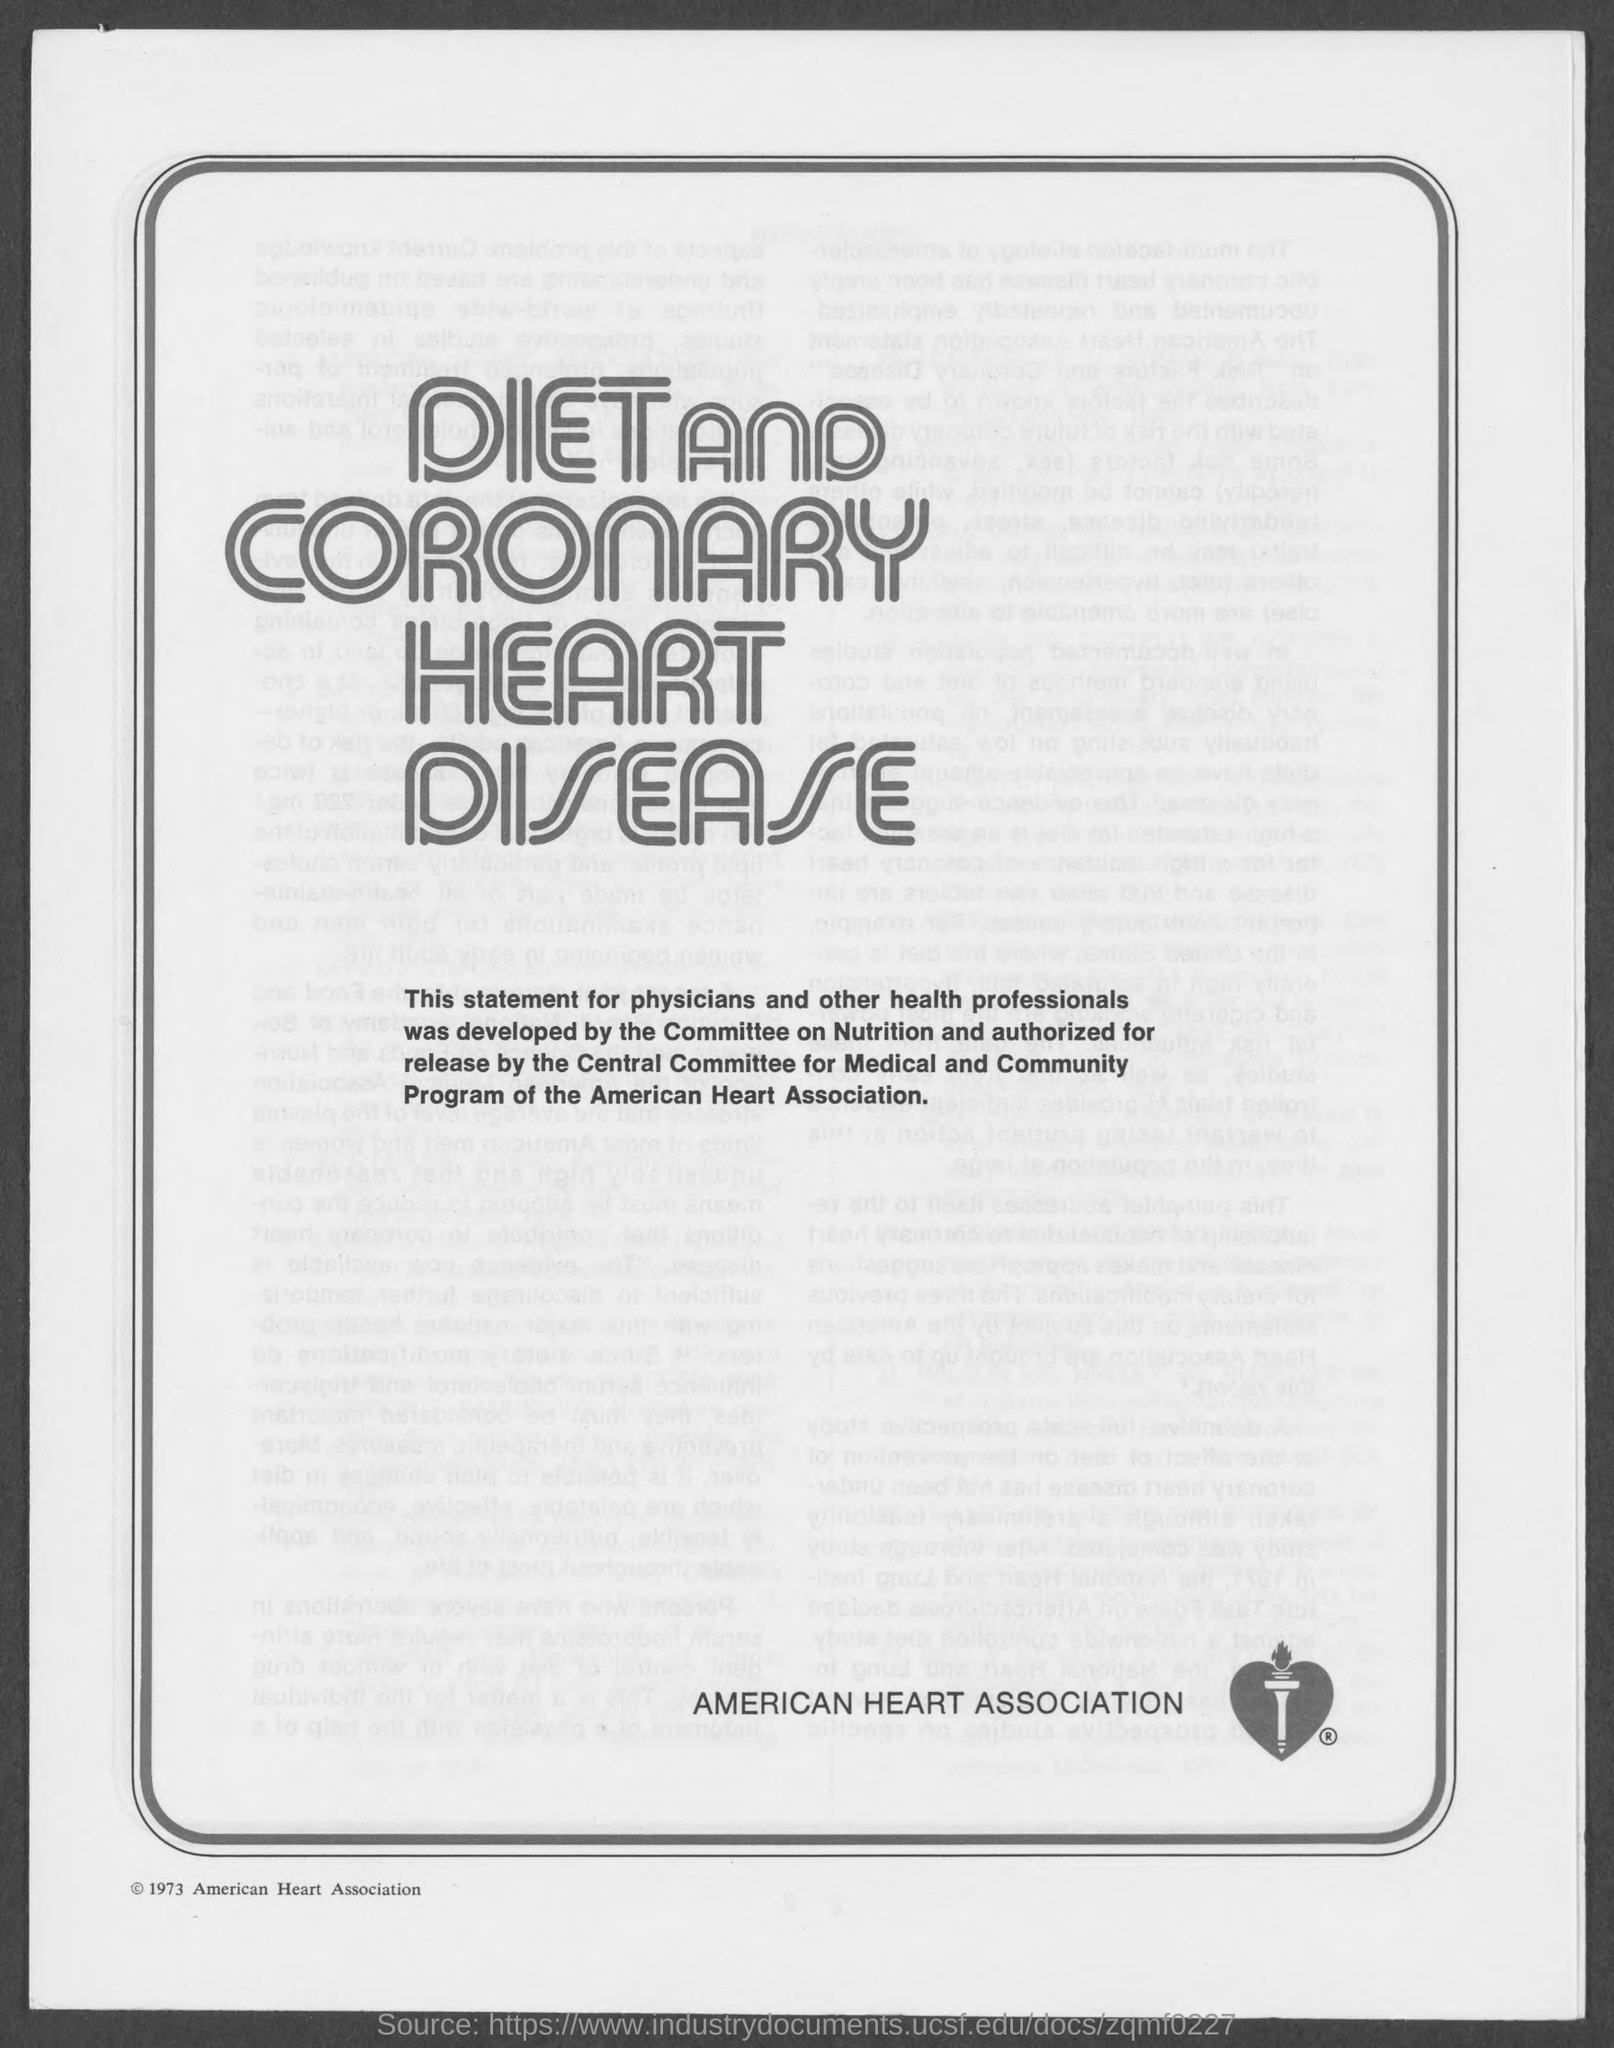Specify some key components in this picture. The American Heart Association is the name of a heart association. 